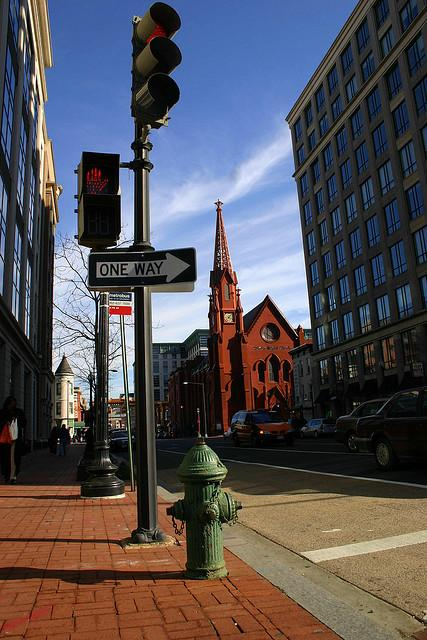Which way can those cars turn?

Choices:
A) their right
B) no turn
C) unclear
D) their left their left 